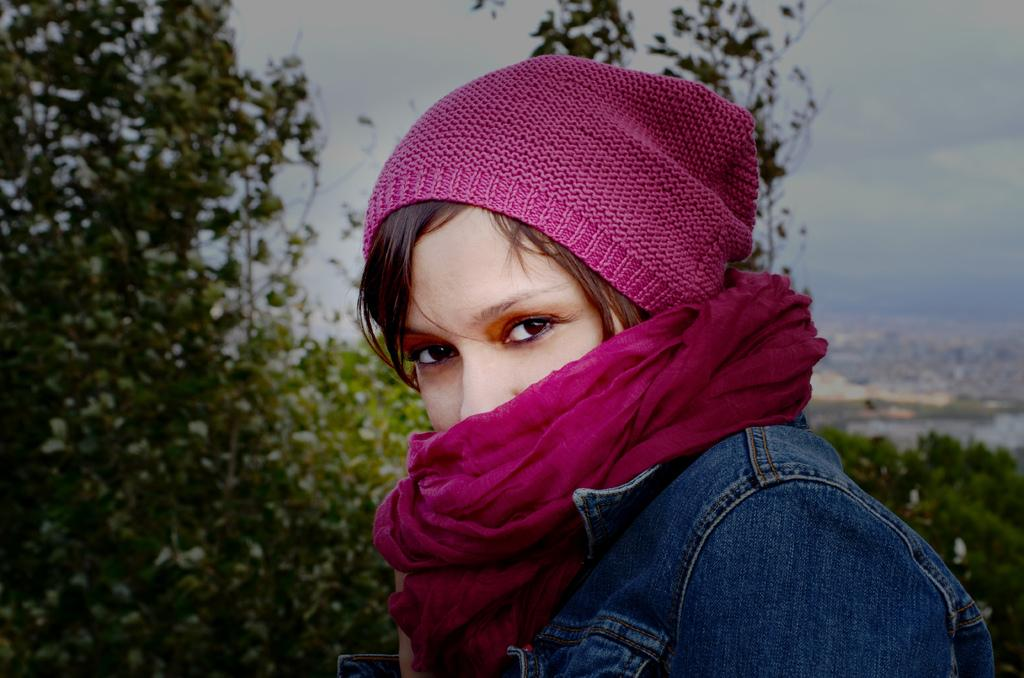Who is present in the image? There is a woman in the image. What is the woman wearing on her head? The woman is wearing a cap. What is the woman wearing around her neck? The woman is wearing a scarf. What can be seen in the background of the image? There are trees and the sky visible in the background of the image. How many ladybugs can be seen on the woman's cap in the image? There are no ladybugs present on the woman's cap in the image. What type of food is the woman holding in the image? There is no food visible in the image. 